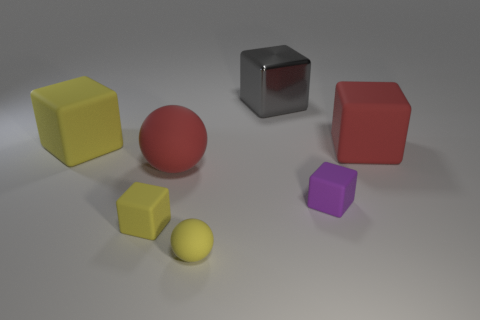What is the yellow ball made of?
Offer a very short reply. Rubber. Is there a thing?
Offer a terse response. Yes. Are there the same number of yellow things in front of the red matte cube and yellow rubber blocks?
Keep it short and to the point. Yes. Are there any other things that have the same material as the large gray thing?
Your response must be concise. No. How many small things are gray metal blocks or yellow rubber cubes?
Provide a succinct answer. 1. What shape is the tiny rubber thing that is the same color as the tiny rubber ball?
Your answer should be compact. Cube. Is the material of the big object that is on the right side of the gray metallic thing the same as the large gray block?
Your response must be concise. No. What is the red object behind the red thing that is left of the small purple matte cube made of?
Offer a terse response. Rubber. What number of large red rubber objects have the same shape as the large gray metallic thing?
Offer a very short reply. 1. What size is the yellow cube behind the large red thing in front of the big matte thing on the right side of the gray block?
Offer a terse response. Large. 